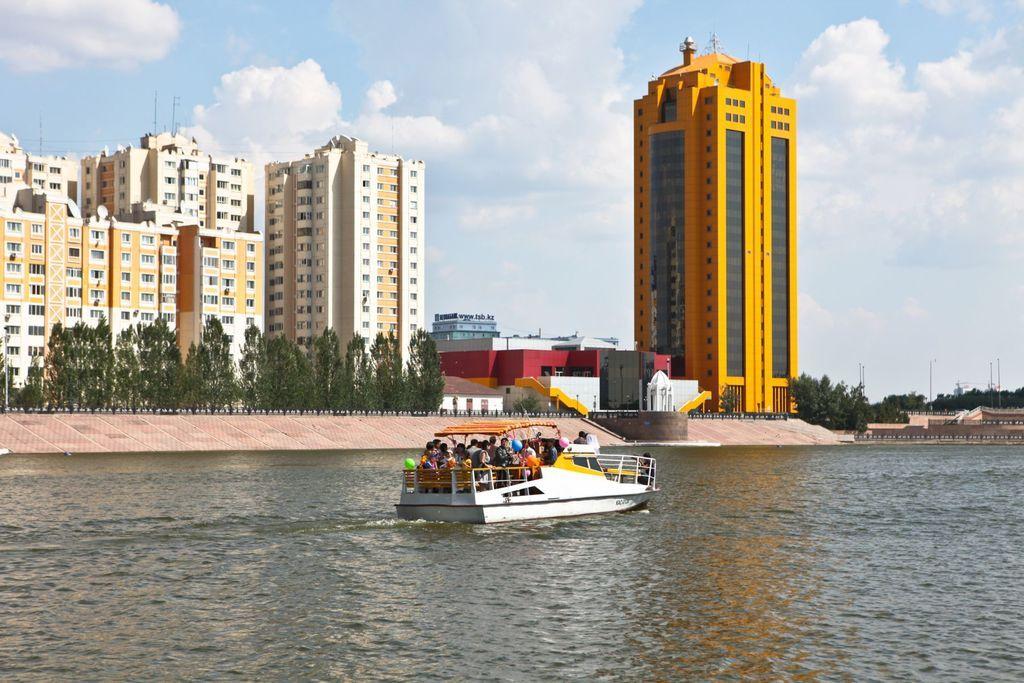Can you describe this image briefly? In this picture I can see few people booting on the water surface, side there are some buildings and trees. 